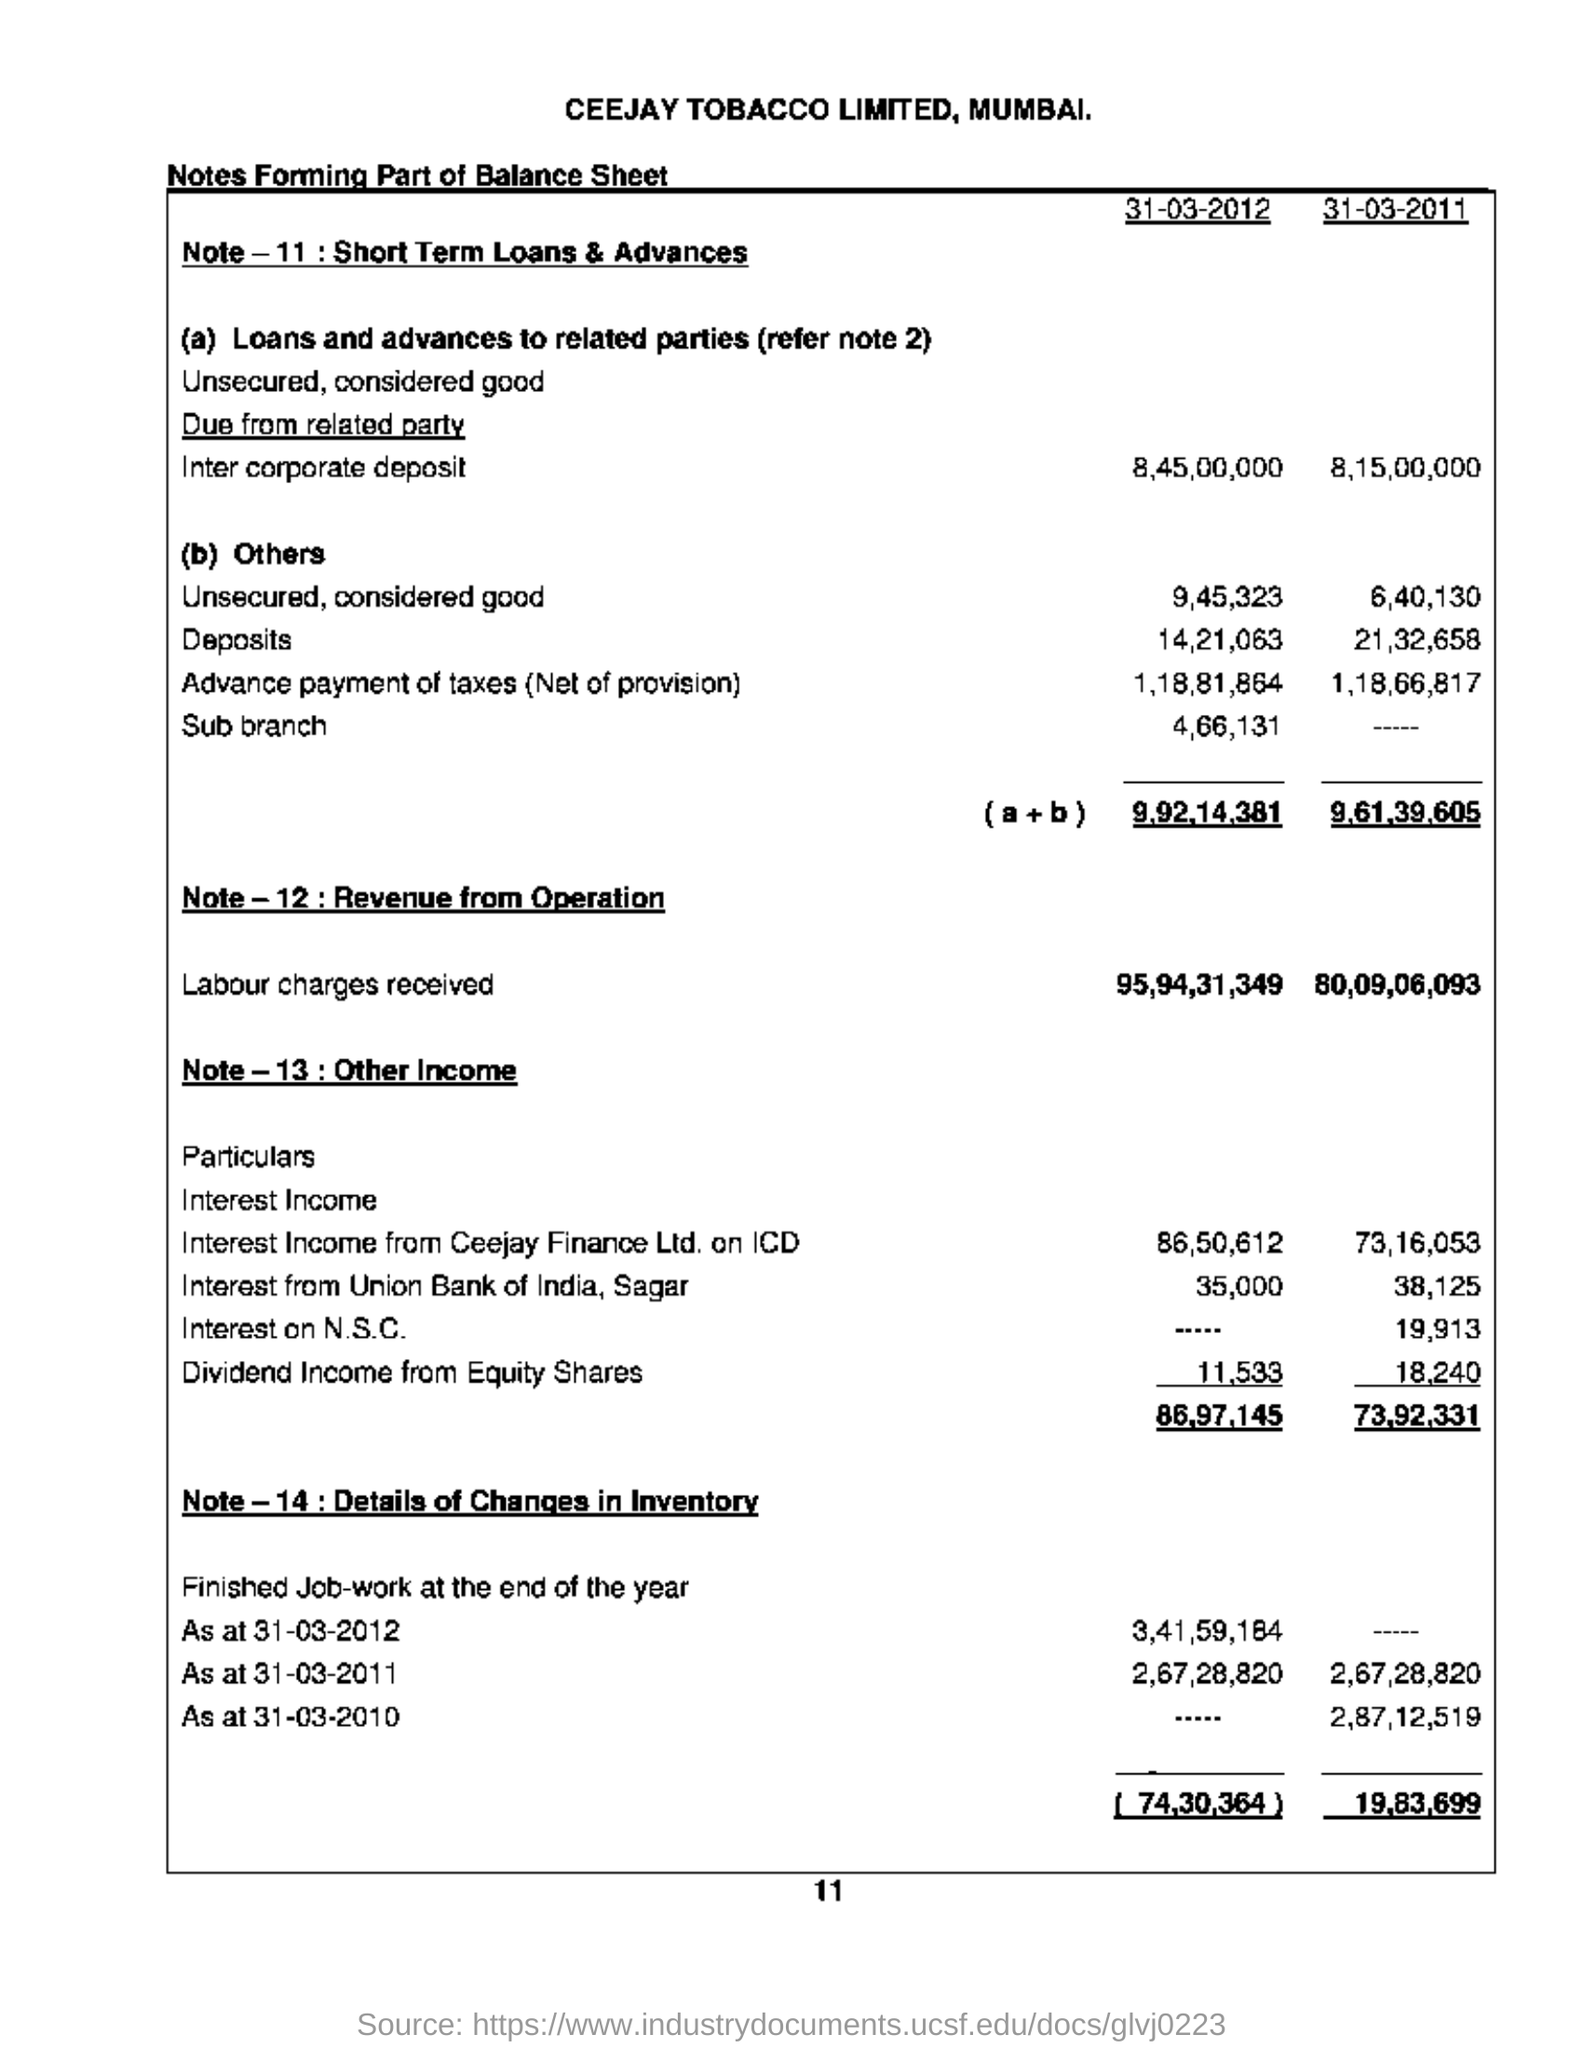Which company is mentioned in the balance sheet?
Offer a terse response. CEEJAY TOBACCO LIMITED. How much labour charges are mentioned in the year 2012?
Provide a short and direct response. 95,94,31,349. The tobacco company is located in which city?
Provide a short and direct response. Mumbai. How much amount of other income mentioned in 2011?
Offer a very short reply. 73,92,331. 